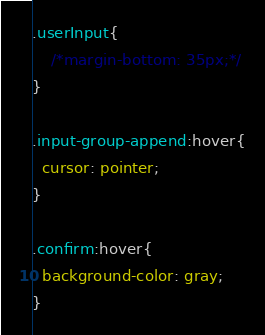Convert code to text. <code><loc_0><loc_0><loc_500><loc_500><_CSS_>.userInput{
    /*margin-bottom: 35px;*/
} 
  
.input-group-append:hover{
  cursor: pointer;
}

.confirm:hover{
  background-color: gray;
}</code> 